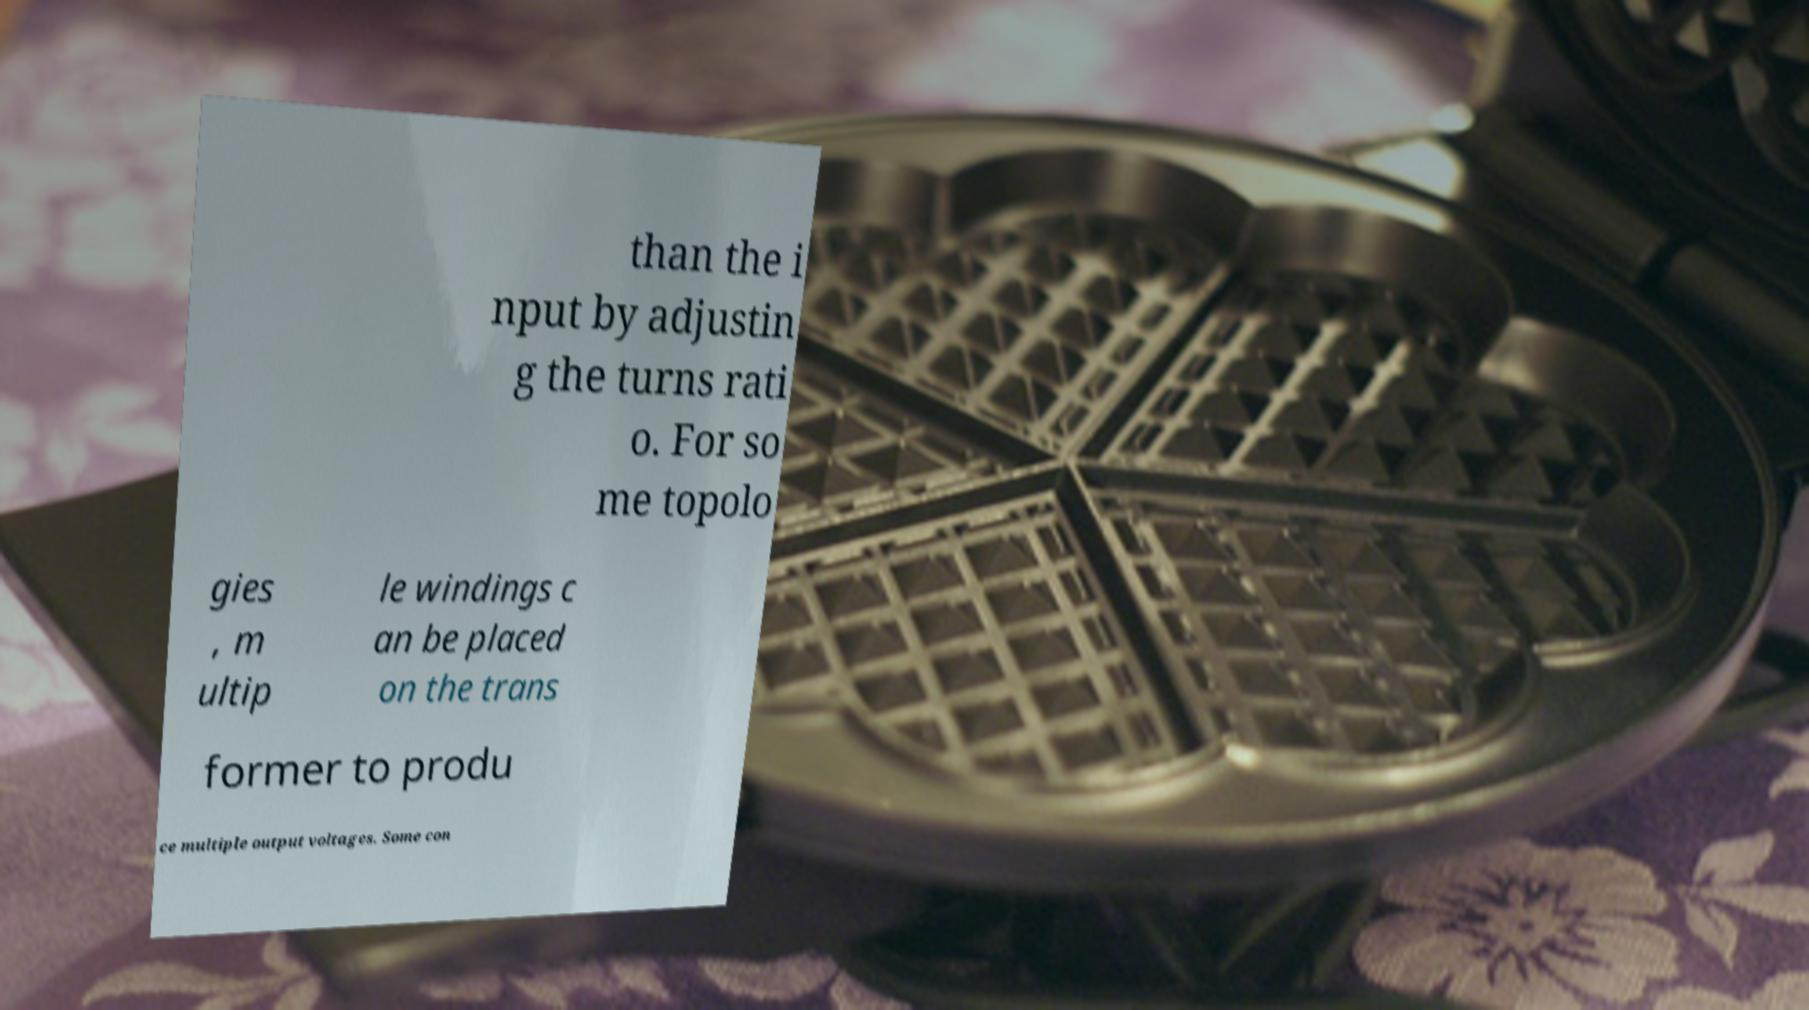What messages or text are displayed in this image? I need them in a readable, typed format. than the i nput by adjustin g the turns rati o. For so me topolo gies , m ultip le windings c an be placed on the trans former to produ ce multiple output voltages. Some con 